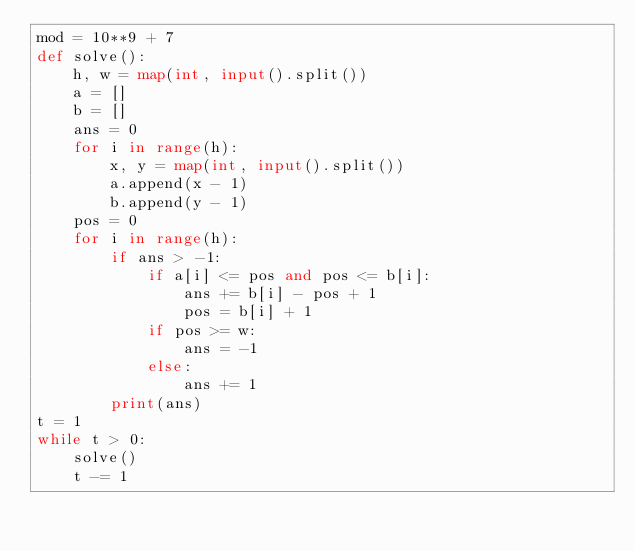Convert code to text. <code><loc_0><loc_0><loc_500><loc_500><_Python_>mod = 10**9 + 7
def solve():
    h, w = map(int, input().split())
    a = []
    b = []
    ans = 0
    for i in range(h):
        x, y = map(int, input().split())
        a.append(x - 1)
        b.append(y - 1)
    pos = 0
    for i in range(h):
        if ans > -1:
            if a[i] <= pos and pos <= b[i]:
                ans += b[i] - pos + 1
                pos = b[i] + 1
            if pos >= w:
                ans = -1
            else:
                ans += 1
        print(ans)
t = 1
while t > 0:
    solve()
    t -= 1
</code> 